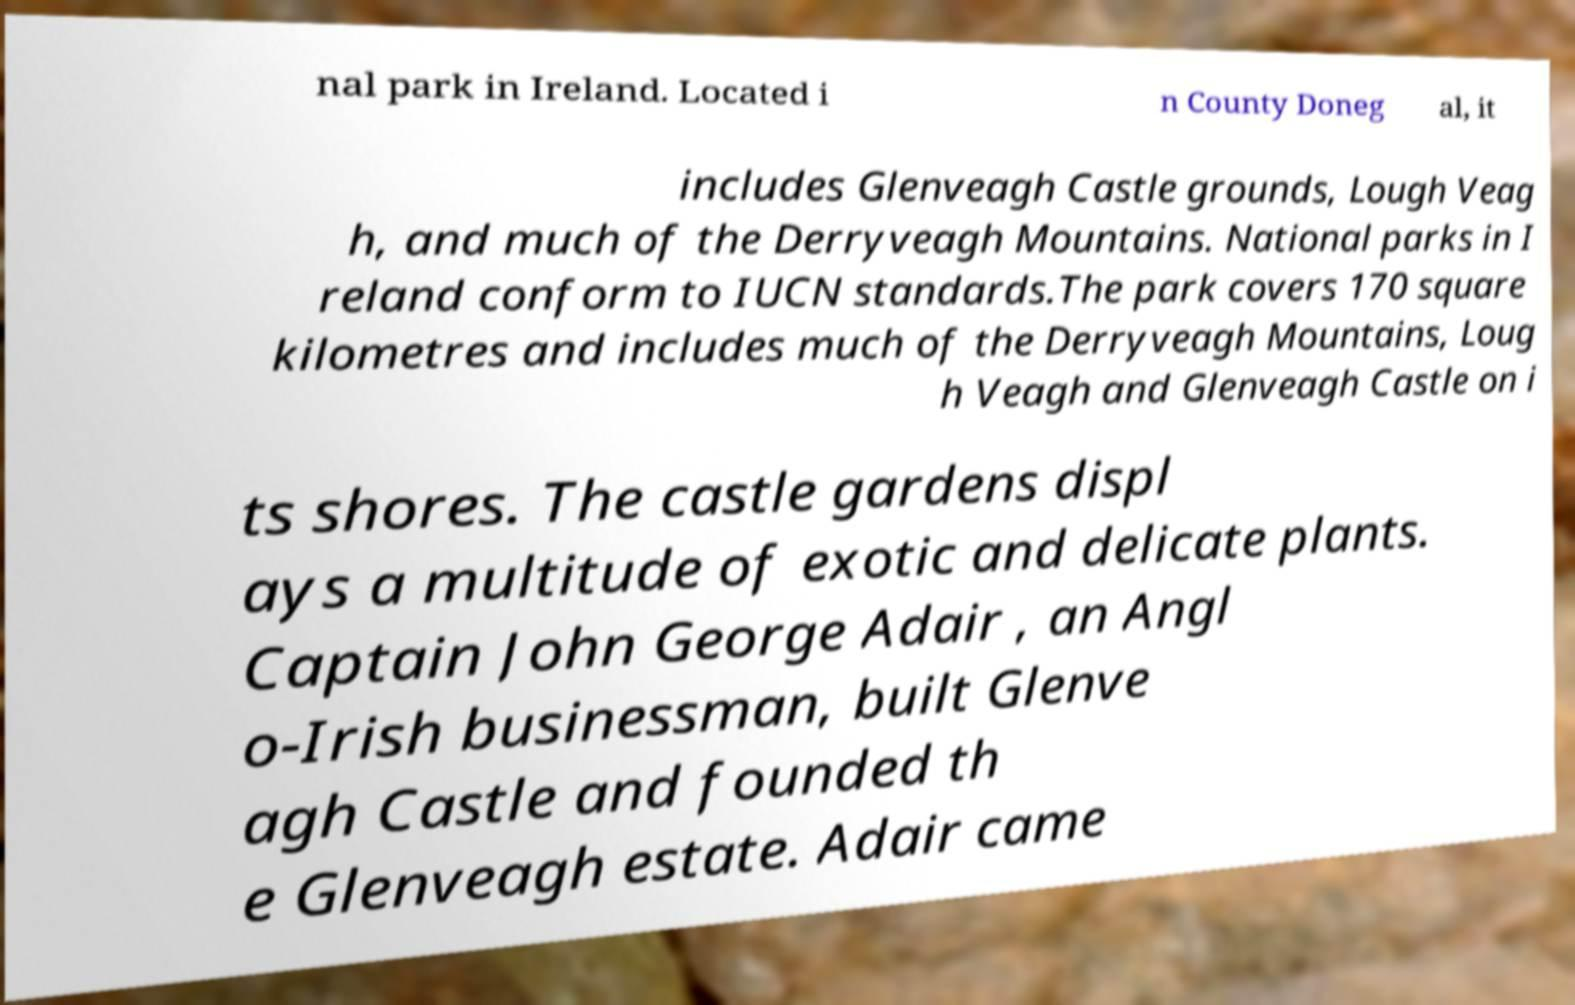Can you read and provide the text displayed in the image?This photo seems to have some interesting text. Can you extract and type it out for me? nal park in Ireland. Located i n County Doneg al, it includes Glenveagh Castle grounds, Lough Veag h, and much of the Derryveagh Mountains. National parks in I reland conform to IUCN standards.The park covers 170 square kilometres and includes much of the Derryveagh Mountains, Loug h Veagh and Glenveagh Castle on i ts shores. The castle gardens displ ays a multitude of exotic and delicate plants. Captain John George Adair , an Angl o-Irish businessman, built Glenve agh Castle and founded th e Glenveagh estate. Adair came 